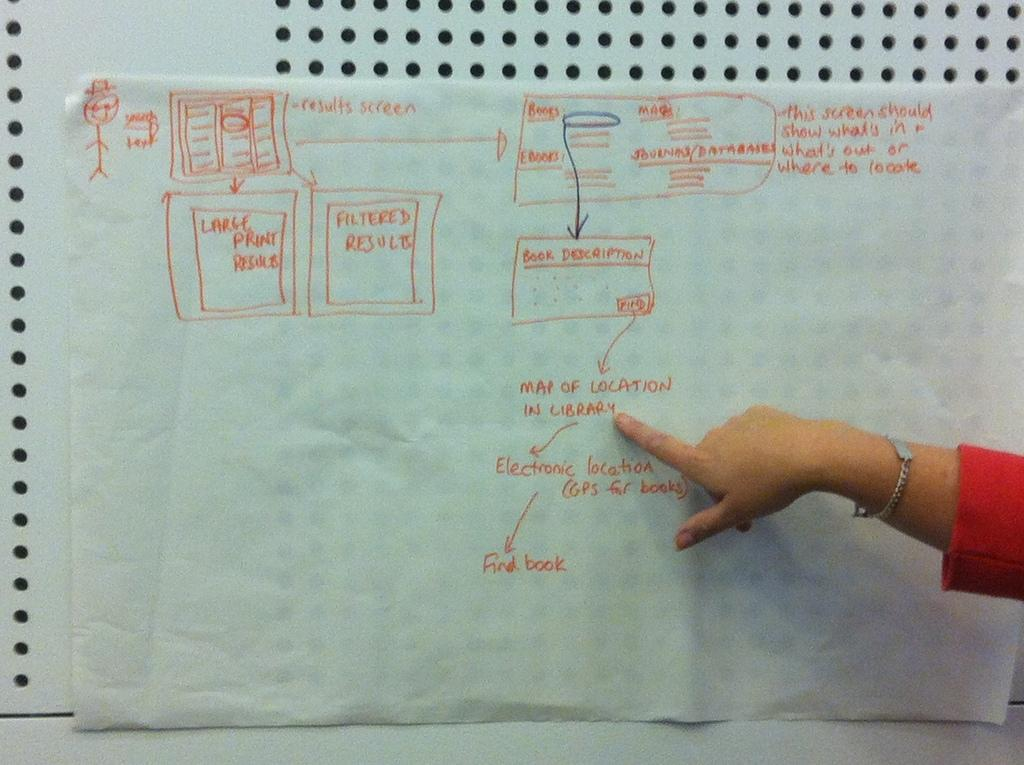What can be seen on the right side of the image? There is a hand on the right side of the image. What is written on the paper in the image? There is text written on a paper in the image. What is visible in the background of the image? There is a wall visible in the background of the image. How does the sheet look like on the top of the wall in the image? There is no sheet present in the image, so it cannot be described on the top of the wall. 